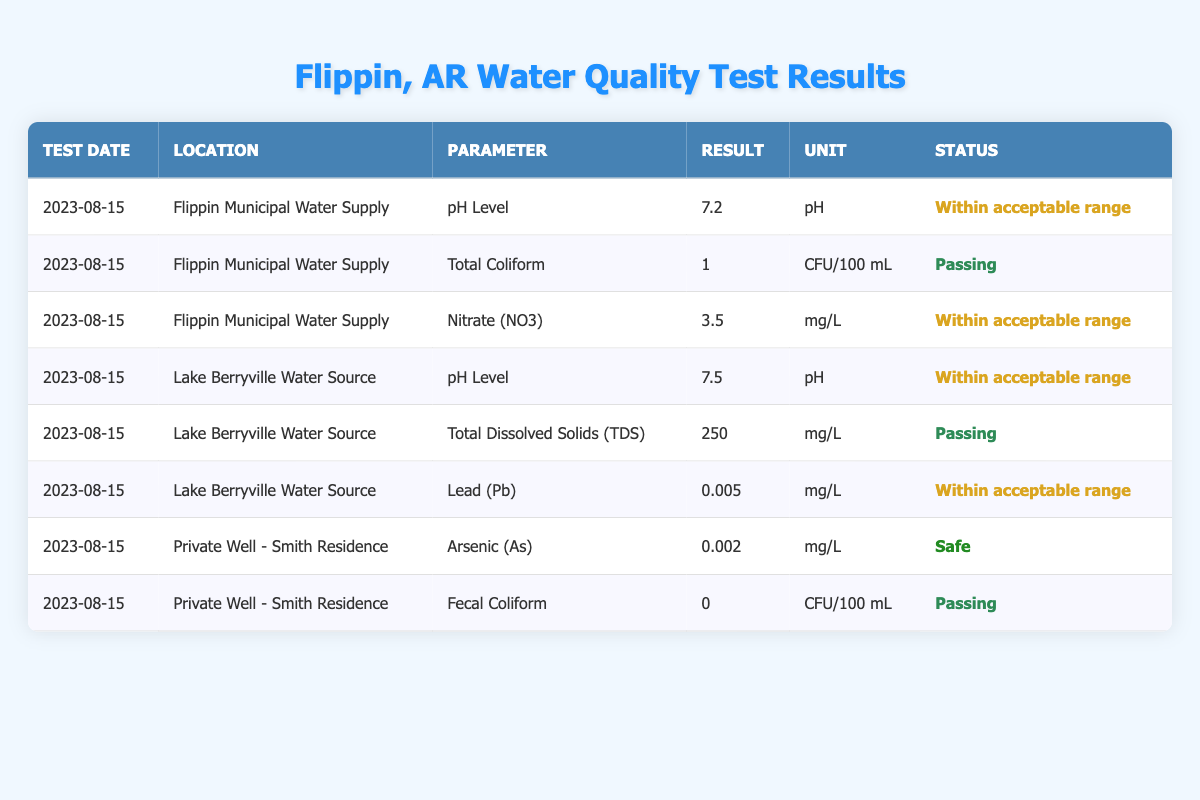What was the pH level of the Flippin Municipal Water Supply on August 15, 2023? The table shows that the pH level for the Flippin Municipal Water Supply on the specified date is 7.2.
Answer: 7.2 Is the Total Coliform level in the Flippin Municipal Water Supply passing? According to the table, the Total Coliform result is 1 CFU/100 mL and the status is marked as 'Passing'.
Answer: Yes What is the result for Lead (Pb) at the Lake Berryville Water Source? The table indicates that the result for Lead (Pb) at the Lake Berryville Water Source is 0.005 mg/L, and it is within the acceptable range.
Answer: 0.005 mg/L What is the average Nitrate (NO3) level across the Flippin Municipal Water Supply and Lake Berryville Water Source? The Nitrate (NO3) level in Flippin Municipal Water Supply is 3.5 mg/L. Lake Berryville Water Source does not have a Nitrate (NO3) entry, so we only use the value from Flippin Municipal Water Supply. Therefore, the average is 3.5 mg/L.
Answer: 3.5 mg/L Is the Arsenic (As) level at the Private Well - Smith Residence safe? The table shows the Arsenic (As) level is 0.002 mg/L, which is marked as 'Safe'.
Answer: Yes Which water source has the highest pH level? The table displays two pH results: 7.2 for Flippin Municipal Water Supply, and 7.5 for Lake Berryville Water Source. Hence, Lake Berryville has the highest pH level at 7.5.
Answer: Lake Berryville Water Source How many water tests in the table had passing results? Counting the statuses in the table, there are 5 passing results: Total Coliform (Flippin Municipal), Fecal Coliform (Private Well), TDS (Lake Berryville), and others that are within acceptable range also qualify. Overall, 6 tests are passing.
Answer: 6 What is the total number of parameters tested across all water sources in the table? The table lists 8 unique tests for water quality across different sources, detailing parameters such as pH level, Total Coliform, Nitrate, and others.
Answer: 8 Did the Lake Berryville Water Source have any unsafe levels? The table does not indicate any unsafe levels for Lake Berryville Water Source; all results are within acceptable or passing status.
Answer: No What was the result for Fecal Coliform at the Private Well - Smith Residence? The table indicates that the Fecal Coliform result for the Private Well - Smith Residence is 0 CFU/100 mL, and it is passing.
Answer: 0 CFU/100 mL 